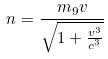<formula> <loc_0><loc_0><loc_500><loc_500>n = \frac { m _ { 9 } v } { \sqrt { 1 + \frac { v ^ { 3 } } { c ^ { 3 } } } }</formula> 